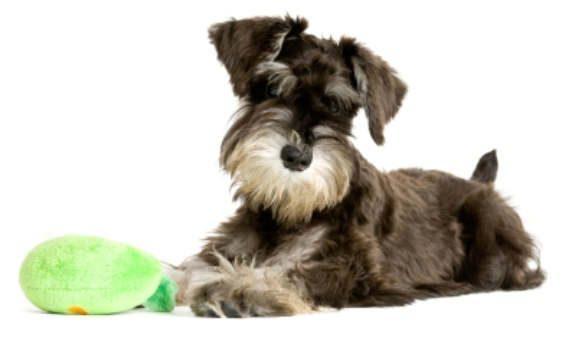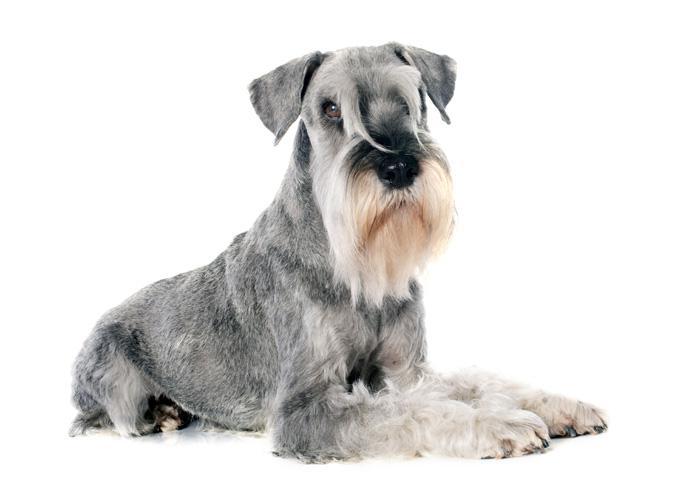The first image is the image on the left, the second image is the image on the right. Evaluate the accuracy of this statement regarding the images: "Each image contains the same number of dogs, and the dogs in both images are posed similarly.". Is it true? Answer yes or no. Yes. The first image is the image on the left, the second image is the image on the right. Evaluate the accuracy of this statement regarding the images: "There are two dogs, both lying down.". Is it true? Answer yes or no. Yes. 